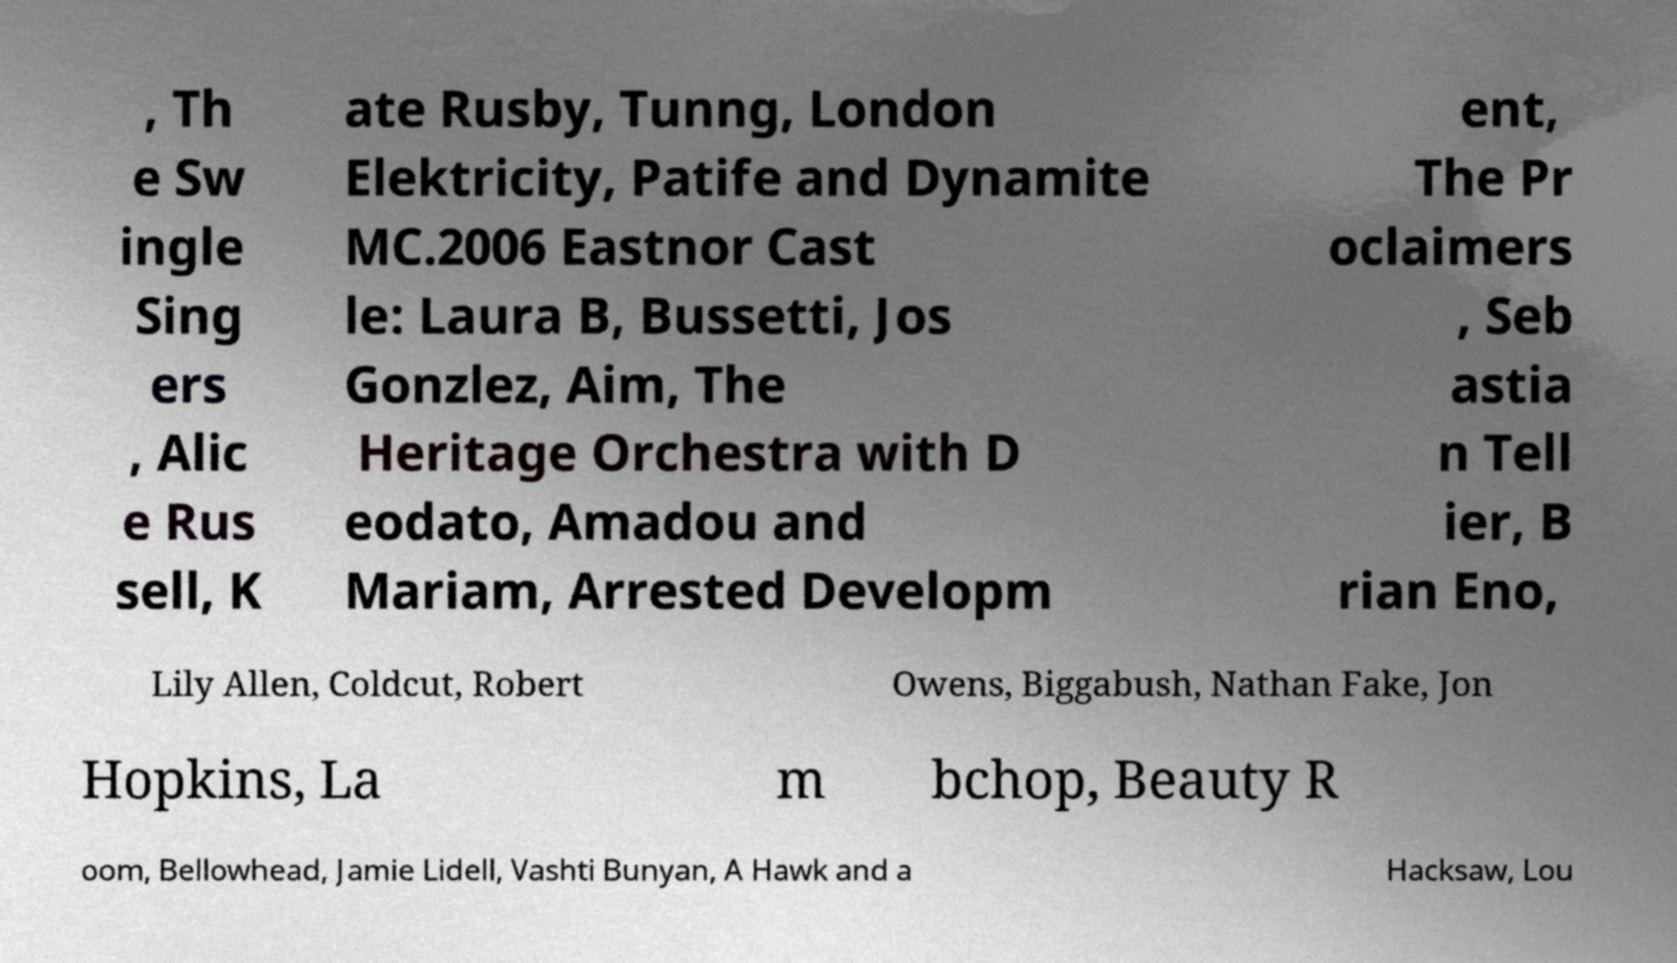I need the written content from this picture converted into text. Can you do that? , Th e Sw ingle Sing ers , Alic e Rus sell, K ate Rusby, Tunng, London Elektricity, Patife and Dynamite MC.2006 Eastnor Cast le: Laura B, Bussetti, Jos Gonzlez, Aim, The Heritage Orchestra with D eodato, Amadou and Mariam, Arrested Developm ent, The Pr oclaimers , Seb astia n Tell ier, B rian Eno, Lily Allen, Coldcut, Robert Owens, Biggabush, Nathan Fake, Jon Hopkins, La m bchop, Beauty R oom, Bellowhead, Jamie Lidell, Vashti Bunyan, A Hawk and a Hacksaw, Lou 